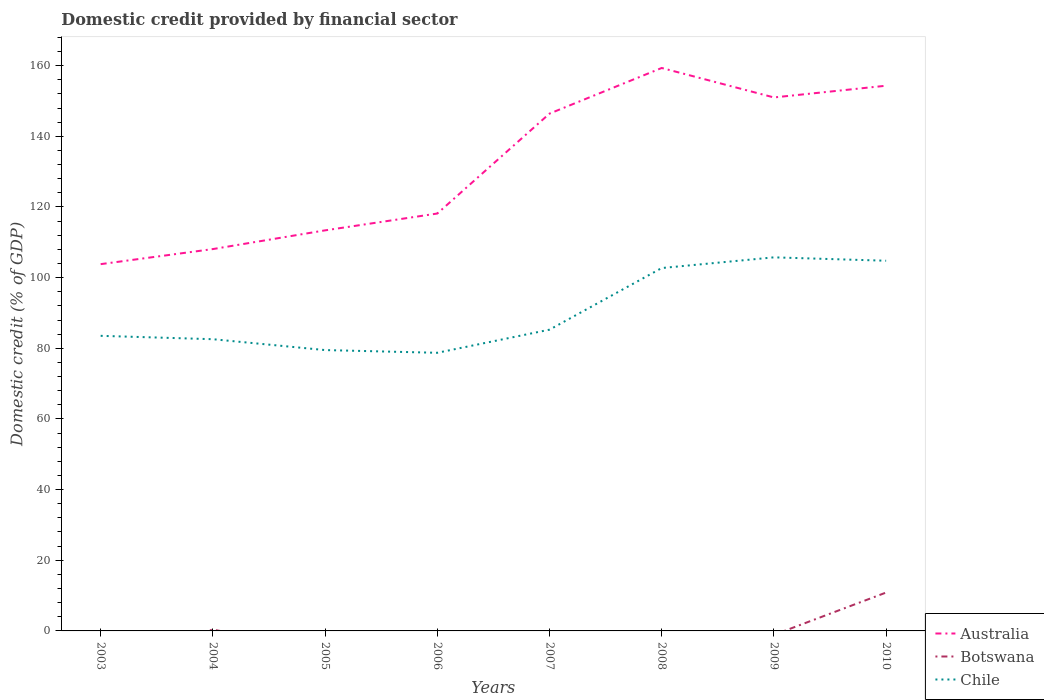How many different coloured lines are there?
Provide a short and direct response. 3. Does the line corresponding to Botswana intersect with the line corresponding to Chile?
Offer a very short reply. No. Is the number of lines equal to the number of legend labels?
Keep it short and to the point. No. Across all years, what is the maximum domestic credit in Chile?
Give a very brief answer. 78.72. What is the total domestic credit in Chile in the graph?
Offer a very short reply. -1.74. What is the difference between the highest and the second highest domestic credit in Australia?
Ensure brevity in your answer.  55.52. What is the difference between the highest and the lowest domestic credit in Chile?
Keep it short and to the point. 3. Is the domestic credit in Botswana strictly greater than the domestic credit in Australia over the years?
Your answer should be very brief. Yes. How many years are there in the graph?
Your answer should be compact. 8. Does the graph contain any zero values?
Offer a terse response. Yes. Where does the legend appear in the graph?
Make the answer very short. Bottom right. How many legend labels are there?
Make the answer very short. 3. How are the legend labels stacked?
Ensure brevity in your answer.  Vertical. What is the title of the graph?
Provide a succinct answer. Domestic credit provided by financial sector. Does "Central Europe" appear as one of the legend labels in the graph?
Your answer should be very brief. No. What is the label or title of the Y-axis?
Offer a very short reply. Domestic credit (% of GDP). What is the Domestic credit (% of GDP) in Australia in 2003?
Your answer should be very brief. 103.81. What is the Domestic credit (% of GDP) of Botswana in 2003?
Your answer should be compact. 0. What is the Domestic credit (% of GDP) of Chile in 2003?
Provide a short and direct response. 83.52. What is the Domestic credit (% of GDP) in Australia in 2004?
Your answer should be compact. 108.08. What is the Domestic credit (% of GDP) in Botswana in 2004?
Ensure brevity in your answer.  0.36. What is the Domestic credit (% of GDP) of Chile in 2004?
Keep it short and to the point. 82.56. What is the Domestic credit (% of GDP) of Australia in 2005?
Make the answer very short. 113.37. What is the Domestic credit (% of GDP) in Botswana in 2005?
Your answer should be very brief. 0. What is the Domestic credit (% of GDP) of Chile in 2005?
Your answer should be compact. 79.49. What is the Domestic credit (% of GDP) of Australia in 2006?
Offer a terse response. 118.14. What is the Domestic credit (% of GDP) in Botswana in 2006?
Your answer should be very brief. 0. What is the Domestic credit (% of GDP) of Chile in 2006?
Offer a very short reply. 78.72. What is the Domestic credit (% of GDP) of Australia in 2007?
Give a very brief answer. 146.42. What is the Domestic credit (% of GDP) of Chile in 2007?
Keep it short and to the point. 85.26. What is the Domestic credit (% of GDP) in Australia in 2008?
Your answer should be compact. 159.33. What is the Domestic credit (% of GDP) in Botswana in 2008?
Offer a terse response. 0. What is the Domestic credit (% of GDP) of Chile in 2008?
Your response must be concise. 102.71. What is the Domestic credit (% of GDP) of Australia in 2009?
Provide a succinct answer. 150.99. What is the Domestic credit (% of GDP) of Chile in 2009?
Provide a succinct answer. 105.73. What is the Domestic credit (% of GDP) of Australia in 2010?
Make the answer very short. 154.31. What is the Domestic credit (% of GDP) in Botswana in 2010?
Make the answer very short. 10.87. What is the Domestic credit (% of GDP) of Chile in 2010?
Make the answer very short. 104.78. Across all years, what is the maximum Domestic credit (% of GDP) of Australia?
Your response must be concise. 159.33. Across all years, what is the maximum Domestic credit (% of GDP) in Botswana?
Keep it short and to the point. 10.87. Across all years, what is the maximum Domestic credit (% of GDP) of Chile?
Your answer should be very brief. 105.73. Across all years, what is the minimum Domestic credit (% of GDP) in Australia?
Your answer should be very brief. 103.81. Across all years, what is the minimum Domestic credit (% of GDP) of Chile?
Offer a terse response. 78.72. What is the total Domestic credit (% of GDP) of Australia in the graph?
Provide a short and direct response. 1054.45. What is the total Domestic credit (% of GDP) of Botswana in the graph?
Provide a short and direct response. 11.23. What is the total Domestic credit (% of GDP) of Chile in the graph?
Provide a short and direct response. 722.78. What is the difference between the Domestic credit (% of GDP) of Australia in 2003 and that in 2004?
Offer a terse response. -4.27. What is the difference between the Domestic credit (% of GDP) of Chile in 2003 and that in 2004?
Keep it short and to the point. 0.96. What is the difference between the Domestic credit (% of GDP) in Australia in 2003 and that in 2005?
Provide a short and direct response. -9.56. What is the difference between the Domestic credit (% of GDP) in Chile in 2003 and that in 2005?
Keep it short and to the point. 4.03. What is the difference between the Domestic credit (% of GDP) of Australia in 2003 and that in 2006?
Provide a short and direct response. -14.33. What is the difference between the Domestic credit (% of GDP) in Chile in 2003 and that in 2006?
Make the answer very short. 4.8. What is the difference between the Domestic credit (% of GDP) in Australia in 2003 and that in 2007?
Keep it short and to the point. -42.61. What is the difference between the Domestic credit (% of GDP) of Chile in 2003 and that in 2007?
Keep it short and to the point. -1.74. What is the difference between the Domestic credit (% of GDP) of Australia in 2003 and that in 2008?
Provide a short and direct response. -55.52. What is the difference between the Domestic credit (% of GDP) of Chile in 2003 and that in 2008?
Provide a short and direct response. -19.19. What is the difference between the Domestic credit (% of GDP) in Australia in 2003 and that in 2009?
Ensure brevity in your answer.  -47.18. What is the difference between the Domestic credit (% of GDP) in Chile in 2003 and that in 2009?
Give a very brief answer. -22.21. What is the difference between the Domestic credit (% of GDP) of Australia in 2003 and that in 2010?
Your response must be concise. -50.51. What is the difference between the Domestic credit (% of GDP) in Chile in 2003 and that in 2010?
Your answer should be very brief. -21.25. What is the difference between the Domestic credit (% of GDP) of Australia in 2004 and that in 2005?
Your response must be concise. -5.3. What is the difference between the Domestic credit (% of GDP) of Chile in 2004 and that in 2005?
Offer a terse response. 3.07. What is the difference between the Domestic credit (% of GDP) of Australia in 2004 and that in 2006?
Make the answer very short. -10.06. What is the difference between the Domestic credit (% of GDP) in Chile in 2004 and that in 2006?
Ensure brevity in your answer.  3.84. What is the difference between the Domestic credit (% of GDP) in Australia in 2004 and that in 2007?
Ensure brevity in your answer.  -38.34. What is the difference between the Domestic credit (% of GDP) in Chile in 2004 and that in 2007?
Provide a short and direct response. -2.7. What is the difference between the Domestic credit (% of GDP) in Australia in 2004 and that in 2008?
Provide a short and direct response. -51.26. What is the difference between the Domestic credit (% of GDP) in Chile in 2004 and that in 2008?
Your response must be concise. -20.15. What is the difference between the Domestic credit (% of GDP) of Australia in 2004 and that in 2009?
Your response must be concise. -42.92. What is the difference between the Domestic credit (% of GDP) in Chile in 2004 and that in 2009?
Provide a short and direct response. -23.17. What is the difference between the Domestic credit (% of GDP) of Australia in 2004 and that in 2010?
Ensure brevity in your answer.  -46.24. What is the difference between the Domestic credit (% of GDP) in Botswana in 2004 and that in 2010?
Your answer should be compact. -10.5. What is the difference between the Domestic credit (% of GDP) in Chile in 2004 and that in 2010?
Your answer should be compact. -22.21. What is the difference between the Domestic credit (% of GDP) in Australia in 2005 and that in 2006?
Your response must be concise. -4.76. What is the difference between the Domestic credit (% of GDP) of Chile in 2005 and that in 2006?
Your answer should be very brief. 0.77. What is the difference between the Domestic credit (% of GDP) of Australia in 2005 and that in 2007?
Your answer should be compact. -33.04. What is the difference between the Domestic credit (% of GDP) in Chile in 2005 and that in 2007?
Ensure brevity in your answer.  -5.77. What is the difference between the Domestic credit (% of GDP) of Australia in 2005 and that in 2008?
Your answer should be very brief. -45.96. What is the difference between the Domestic credit (% of GDP) of Chile in 2005 and that in 2008?
Offer a terse response. -23.22. What is the difference between the Domestic credit (% of GDP) in Australia in 2005 and that in 2009?
Offer a terse response. -37.62. What is the difference between the Domestic credit (% of GDP) in Chile in 2005 and that in 2009?
Keep it short and to the point. -26.24. What is the difference between the Domestic credit (% of GDP) of Australia in 2005 and that in 2010?
Provide a succinct answer. -40.94. What is the difference between the Domestic credit (% of GDP) in Chile in 2005 and that in 2010?
Your answer should be very brief. -25.28. What is the difference between the Domestic credit (% of GDP) of Australia in 2006 and that in 2007?
Offer a very short reply. -28.28. What is the difference between the Domestic credit (% of GDP) in Chile in 2006 and that in 2007?
Your answer should be very brief. -6.54. What is the difference between the Domestic credit (% of GDP) in Australia in 2006 and that in 2008?
Offer a terse response. -41.2. What is the difference between the Domestic credit (% of GDP) of Chile in 2006 and that in 2008?
Ensure brevity in your answer.  -23.99. What is the difference between the Domestic credit (% of GDP) of Australia in 2006 and that in 2009?
Ensure brevity in your answer.  -32.86. What is the difference between the Domestic credit (% of GDP) of Chile in 2006 and that in 2009?
Make the answer very short. -27.01. What is the difference between the Domestic credit (% of GDP) of Australia in 2006 and that in 2010?
Your response must be concise. -36.18. What is the difference between the Domestic credit (% of GDP) in Chile in 2006 and that in 2010?
Your answer should be very brief. -26.06. What is the difference between the Domestic credit (% of GDP) of Australia in 2007 and that in 2008?
Give a very brief answer. -12.92. What is the difference between the Domestic credit (% of GDP) of Chile in 2007 and that in 2008?
Your response must be concise. -17.45. What is the difference between the Domestic credit (% of GDP) in Australia in 2007 and that in 2009?
Offer a terse response. -4.58. What is the difference between the Domestic credit (% of GDP) of Chile in 2007 and that in 2009?
Ensure brevity in your answer.  -20.47. What is the difference between the Domestic credit (% of GDP) of Australia in 2007 and that in 2010?
Provide a succinct answer. -7.9. What is the difference between the Domestic credit (% of GDP) in Chile in 2007 and that in 2010?
Provide a succinct answer. -19.51. What is the difference between the Domestic credit (% of GDP) in Australia in 2008 and that in 2009?
Your answer should be very brief. 8.34. What is the difference between the Domestic credit (% of GDP) in Chile in 2008 and that in 2009?
Offer a terse response. -3.02. What is the difference between the Domestic credit (% of GDP) in Australia in 2008 and that in 2010?
Your response must be concise. 5.02. What is the difference between the Domestic credit (% of GDP) of Chile in 2008 and that in 2010?
Your response must be concise. -2.07. What is the difference between the Domestic credit (% of GDP) in Australia in 2009 and that in 2010?
Your answer should be compact. -3.32. What is the difference between the Domestic credit (% of GDP) of Chile in 2009 and that in 2010?
Give a very brief answer. 0.96. What is the difference between the Domestic credit (% of GDP) of Australia in 2003 and the Domestic credit (% of GDP) of Botswana in 2004?
Provide a short and direct response. 103.45. What is the difference between the Domestic credit (% of GDP) of Australia in 2003 and the Domestic credit (% of GDP) of Chile in 2004?
Offer a very short reply. 21.24. What is the difference between the Domestic credit (% of GDP) in Australia in 2003 and the Domestic credit (% of GDP) in Chile in 2005?
Your answer should be very brief. 24.32. What is the difference between the Domestic credit (% of GDP) of Australia in 2003 and the Domestic credit (% of GDP) of Chile in 2006?
Offer a terse response. 25.09. What is the difference between the Domestic credit (% of GDP) in Australia in 2003 and the Domestic credit (% of GDP) in Chile in 2007?
Your answer should be very brief. 18.55. What is the difference between the Domestic credit (% of GDP) of Australia in 2003 and the Domestic credit (% of GDP) of Chile in 2008?
Make the answer very short. 1.1. What is the difference between the Domestic credit (% of GDP) in Australia in 2003 and the Domestic credit (% of GDP) in Chile in 2009?
Provide a succinct answer. -1.93. What is the difference between the Domestic credit (% of GDP) of Australia in 2003 and the Domestic credit (% of GDP) of Botswana in 2010?
Your answer should be very brief. 92.94. What is the difference between the Domestic credit (% of GDP) of Australia in 2003 and the Domestic credit (% of GDP) of Chile in 2010?
Give a very brief answer. -0.97. What is the difference between the Domestic credit (% of GDP) in Australia in 2004 and the Domestic credit (% of GDP) in Chile in 2005?
Keep it short and to the point. 28.59. What is the difference between the Domestic credit (% of GDP) in Botswana in 2004 and the Domestic credit (% of GDP) in Chile in 2005?
Provide a short and direct response. -79.13. What is the difference between the Domestic credit (% of GDP) in Australia in 2004 and the Domestic credit (% of GDP) in Chile in 2006?
Give a very brief answer. 29.36. What is the difference between the Domestic credit (% of GDP) in Botswana in 2004 and the Domestic credit (% of GDP) in Chile in 2006?
Keep it short and to the point. -78.36. What is the difference between the Domestic credit (% of GDP) in Australia in 2004 and the Domestic credit (% of GDP) in Chile in 2007?
Your answer should be compact. 22.81. What is the difference between the Domestic credit (% of GDP) of Botswana in 2004 and the Domestic credit (% of GDP) of Chile in 2007?
Give a very brief answer. -84.9. What is the difference between the Domestic credit (% of GDP) in Australia in 2004 and the Domestic credit (% of GDP) in Chile in 2008?
Provide a short and direct response. 5.37. What is the difference between the Domestic credit (% of GDP) in Botswana in 2004 and the Domestic credit (% of GDP) in Chile in 2008?
Make the answer very short. -102.35. What is the difference between the Domestic credit (% of GDP) in Australia in 2004 and the Domestic credit (% of GDP) in Chile in 2009?
Offer a terse response. 2.34. What is the difference between the Domestic credit (% of GDP) of Botswana in 2004 and the Domestic credit (% of GDP) of Chile in 2009?
Your answer should be very brief. -105.37. What is the difference between the Domestic credit (% of GDP) in Australia in 2004 and the Domestic credit (% of GDP) in Botswana in 2010?
Ensure brevity in your answer.  97.21. What is the difference between the Domestic credit (% of GDP) of Australia in 2004 and the Domestic credit (% of GDP) of Chile in 2010?
Give a very brief answer. 3.3. What is the difference between the Domestic credit (% of GDP) in Botswana in 2004 and the Domestic credit (% of GDP) in Chile in 2010?
Offer a very short reply. -104.41. What is the difference between the Domestic credit (% of GDP) in Australia in 2005 and the Domestic credit (% of GDP) in Chile in 2006?
Ensure brevity in your answer.  34.65. What is the difference between the Domestic credit (% of GDP) in Australia in 2005 and the Domestic credit (% of GDP) in Chile in 2007?
Make the answer very short. 28.11. What is the difference between the Domestic credit (% of GDP) in Australia in 2005 and the Domestic credit (% of GDP) in Chile in 2008?
Your answer should be compact. 10.66. What is the difference between the Domestic credit (% of GDP) of Australia in 2005 and the Domestic credit (% of GDP) of Chile in 2009?
Make the answer very short. 7.64. What is the difference between the Domestic credit (% of GDP) in Australia in 2005 and the Domestic credit (% of GDP) in Botswana in 2010?
Ensure brevity in your answer.  102.51. What is the difference between the Domestic credit (% of GDP) in Australia in 2005 and the Domestic credit (% of GDP) in Chile in 2010?
Your answer should be very brief. 8.6. What is the difference between the Domestic credit (% of GDP) in Australia in 2006 and the Domestic credit (% of GDP) in Chile in 2007?
Provide a short and direct response. 32.87. What is the difference between the Domestic credit (% of GDP) of Australia in 2006 and the Domestic credit (% of GDP) of Chile in 2008?
Your response must be concise. 15.43. What is the difference between the Domestic credit (% of GDP) in Australia in 2006 and the Domestic credit (% of GDP) in Chile in 2009?
Give a very brief answer. 12.4. What is the difference between the Domestic credit (% of GDP) of Australia in 2006 and the Domestic credit (% of GDP) of Botswana in 2010?
Provide a succinct answer. 107.27. What is the difference between the Domestic credit (% of GDP) in Australia in 2006 and the Domestic credit (% of GDP) in Chile in 2010?
Keep it short and to the point. 13.36. What is the difference between the Domestic credit (% of GDP) of Australia in 2007 and the Domestic credit (% of GDP) of Chile in 2008?
Your answer should be very brief. 43.71. What is the difference between the Domestic credit (% of GDP) of Australia in 2007 and the Domestic credit (% of GDP) of Chile in 2009?
Keep it short and to the point. 40.68. What is the difference between the Domestic credit (% of GDP) in Australia in 2007 and the Domestic credit (% of GDP) in Botswana in 2010?
Your answer should be very brief. 135.55. What is the difference between the Domestic credit (% of GDP) of Australia in 2007 and the Domestic credit (% of GDP) of Chile in 2010?
Your answer should be compact. 41.64. What is the difference between the Domestic credit (% of GDP) of Australia in 2008 and the Domestic credit (% of GDP) of Chile in 2009?
Provide a short and direct response. 53.6. What is the difference between the Domestic credit (% of GDP) in Australia in 2008 and the Domestic credit (% of GDP) in Botswana in 2010?
Your answer should be very brief. 148.47. What is the difference between the Domestic credit (% of GDP) of Australia in 2008 and the Domestic credit (% of GDP) of Chile in 2010?
Your answer should be compact. 54.56. What is the difference between the Domestic credit (% of GDP) of Australia in 2009 and the Domestic credit (% of GDP) of Botswana in 2010?
Your response must be concise. 140.13. What is the difference between the Domestic credit (% of GDP) in Australia in 2009 and the Domestic credit (% of GDP) in Chile in 2010?
Offer a very short reply. 46.22. What is the average Domestic credit (% of GDP) of Australia per year?
Offer a terse response. 131.81. What is the average Domestic credit (% of GDP) in Botswana per year?
Your response must be concise. 1.4. What is the average Domestic credit (% of GDP) in Chile per year?
Your response must be concise. 90.35. In the year 2003, what is the difference between the Domestic credit (% of GDP) of Australia and Domestic credit (% of GDP) of Chile?
Offer a terse response. 20.29. In the year 2004, what is the difference between the Domestic credit (% of GDP) in Australia and Domestic credit (% of GDP) in Botswana?
Your answer should be very brief. 107.72. In the year 2004, what is the difference between the Domestic credit (% of GDP) in Australia and Domestic credit (% of GDP) in Chile?
Give a very brief answer. 25.51. In the year 2004, what is the difference between the Domestic credit (% of GDP) in Botswana and Domestic credit (% of GDP) in Chile?
Make the answer very short. -82.2. In the year 2005, what is the difference between the Domestic credit (% of GDP) in Australia and Domestic credit (% of GDP) in Chile?
Give a very brief answer. 33.88. In the year 2006, what is the difference between the Domestic credit (% of GDP) of Australia and Domestic credit (% of GDP) of Chile?
Provide a succinct answer. 39.42. In the year 2007, what is the difference between the Domestic credit (% of GDP) of Australia and Domestic credit (% of GDP) of Chile?
Your response must be concise. 61.15. In the year 2008, what is the difference between the Domestic credit (% of GDP) in Australia and Domestic credit (% of GDP) in Chile?
Provide a short and direct response. 56.62. In the year 2009, what is the difference between the Domestic credit (% of GDP) of Australia and Domestic credit (% of GDP) of Chile?
Provide a succinct answer. 45.26. In the year 2010, what is the difference between the Domestic credit (% of GDP) of Australia and Domestic credit (% of GDP) of Botswana?
Your answer should be compact. 143.45. In the year 2010, what is the difference between the Domestic credit (% of GDP) in Australia and Domestic credit (% of GDP) in Chile?
Provide a succinct answer. 49.54. In the year 2010, what is the difference between the Domestic credit (% of GDP) in Botswana and Domestic credit (% of GDP) in Chile?
Provide a short and direct response. -93.91. What is the ratio of the Domestic credit (% of GDP) in Australia in 2003 to that in 2004?
Offer a very short reply. 0.96. What is the ratio of the Domestic credit (% of GDP) of Chile in 2003 to that in 2004?
Provide a succinct answer. 1.01. What is the ratio of the Domestic credit (% of GDP) in Australia in 2003 to that in 2005?
Give a very brief answer. 0.92. What is the ratio of the Domestic credit (% of GDP) in Chile in 2003 to that in 2005?
Your answer should be very brief. 1.05. What is the ratio of the Domestic credit (% of GDP) of Australia in 2003 to that in 2006?
Your answer should be very brief. 0.88. What is the ratio of the Domestic credit (% of GDP) of Chile in 2003 to that in 2006?
Make the answer very short. 1.06. What is the ratio of the Domestic credit (% of GDP) of Australia in 2003 to that in 2007?
Provide a succinct answer. 0.71. What is the ratio of the Domestic credit (% of GDP) in Chile in 2003 to that in 2007?
Provide a succinct answer. 0.98. What is the ratio of the Domestic credit (% of GDP) of Australia in 2003 to that in 2008?
Your answer should be compact. 0.65. What is the ratio of the Domestic credit (% of GDP) of Chile in 2003 to that in 2008?
Provide a short and direct response. 0.81. What is the ratio of the Domestic credit (% of GDP) of Australia in 2003 to that in 2009?
Offer a terse response. 0.69. What is the ratio of the Domestic credit (% of GDP) in Chile in 2003 to that in 2009?
Provide a succinct answer. 0.79. What is the ratio of the Domestic credit (% of GDP) in Australia in 2003 to that in 2010?
Make the answer very short. 0.67. What is the ratio of the Domestic credit (% of GDP) of Chile in 2003 to that in 2010?
Offer a terse response. 0.8. What is the ratio of the Domestic credit (% of GDP) of Australia in 2004 to that in 2005?
Keep it short and to the point. 0.95. What is the ratio of the Domestic credit (% of GDP) of Chile in 2004 to that in 2005?
Make the answer very short. 1.04. What is the ratio of the Domestic credit (% of GDP) in Australia in 2004 to that in 2006?
Offer a very short reply. 0.91. What is the ratio of the Domestic credit (% of GDP) in Chile in 2004 to that in 2006?
Your answer should be compact. 1.05. What is the ratio of the Domestic credit (% of GDP) in Australia in 2004 to that in 2007?
Your response must be concise. 0.74. What is the ratio of the Domestic credit (% of GDP) of Chile in 2004 to that in 2007?
Offer a very short reply. 0.97. What is the ratio of the Domestic credit (% of GDP) in Australia in 2004 to that in 2008?
Give a very brief answer. 0.68. What is the ratio of the Domestic credit (% of GDP) in Chile in 2004 to that in 2008?
Provide a short and direct response. 0.8. What is the ratio of the Domestic credit (% of GDP) in Australia in 2004 to that in 2009?
Offer a very short reply. 0.72. What is the ratio of the Domestic credit (% of GDP) in Chile in 2004 to that in 2009?
Your answer should be compact. 0.78. What is the ratio of the Domestic credit (% of GDP) of Australia in 2004 to that in 2010?
Offer a terse response. 0.7. What is the ratio of the Domestic credit (% of GDP) in Botswana in 2004 to that in 2010?
Ensure brevity in your answer.  0.03. What is the ratio of the Domestic credit (% of GDP) in Chile in 2004 to that in 2010?
Provide a succinct answer. 0.79. What is the ratio of the Domestic credit (% of GDP) of Australia in 2005 to that in 2006?
Ensure brevity in your answer.  0.96. What is the ratio of the Domestic credit (% of GDP) in Chile in 2005 to that in 2006?
Your response must be concise. 1.01. What is the ratio of the Domestic credit (% of GDP) in Australia in 2005 to that in 2007?
Your answer should be compact. 0.77. What is the ratio of the Domestic credit (% of GDP) in Chile in 2005 to that in 2007?
Your answer should be very brief. 0.93. What is the ratio of the Domestic credit (% of GDP) of Australia in 2005 to that in 2008?
Give a very brief answer. 0.71. What is the ratio of the Domestic credit (% of GDP) of Chile in 2005 to that in 2008?
Keep it short and to the point. 0.77. What is the ratio of the Domestic credit (% of GDP) of Australia in 2005 to that in 2009?
Ensure brevity in your answer.  0.75. What is the ratio of the Domestic credit (% of GDP) of Chile in 2005 to that in 2009?
Provide a short and direct response. 0.75. What is the ratio of the Domestic credit (% of GDP) in Australia in 2005 to that in 2010?
Offer a terse response. 0.73. What is the ratio of the Domestic credit (% of GDP) of Chile in 2005 to that in 2010?
Ensure brevity in your answer.  0.76. What is the ratio of the Domestic credit (% of GDP) of Australia in 2006 to that in 2007?
Your answer should be very brief. 0.81. What is the ratio of the Domestic credit (% of GDP) of Chile in 2006 to that in 2007?
Your answer should be very brief. 0.92. What is the ratio of the Domestic credit (% of GDP) in Australia in 2006 to that in 2008?
Your answer should be compact. 0.74. What is the ratio of the Domestic credit (% of GDP) of Chile in 2006 to that in 2008?
Give a very brief answer. 0.77. What is the ratio of the Domestic credit (% of GDP) in Australia in 2006 to that in 2009?
Your answer should be very brief. 0.78. What is the ratio of the Domestic credit (% of GDP) in Chile in 2006 to that in 2009?
Give a very brief answer. 0.74. What is the ratio of the Domestic credit (% of GDP) in Australia in 2006 to that in 2010?
Offer a very short reply. 0.77. What is the ratio of the Domestic credit (% of GDP) of Chile in 2006 to that in 2010?
Give a very brief answer. 0.75. What is the ratio of the Domestic credit (% of GDP) of Australia in 2007 to that in 2008?
Your answer should be compact. 0.92. What is the ratio of the Domestic credit (% of GDP) of Chile in 2007 to that in 2008?
Provide a succinct answer. 0.83. What is the ratio of the Domestic credit (% of GDP) in Australia in 2007 to that in 2009?
Your answer should be compact. 0.97. What is the ratio of the Domestic credit (% of GDP) of Chile in 2007 to that in 2009?
Provide a short and direct response. 0.81. What is the ratio of the Domestic credit (% of GDP) in Australia in 2007 to that in 2010?
Provide a succinct answer. 0.95. What is the ratio of the Domestic credit (% of GDP) in Chile in 2007 to that in 2010?
Offer a very short reply. 0.81. What is the ratio of the Domestic credit (% of GDP) in Australia in 2008 to that in 2009?
Your answer should be very brief. 1.06. What is the ratio of the Domestic credit (% of GDP) in Chile in 2008 to that in 2009?
Keep it short and to the point. 0.97. What is the ratio of the Domestic credit (% of GDP) in Australia in 2008 to that in 2010?
Your answer should be compact. 1.03. What is the ratio of the Domestic credit (% of GDP) in Chile in 2008 to that in 2010?
Your answer should be compact. 0.98. What is the ratio of the Domestic credit (% of GDP) in Australia in 2009 to that in 2010?
Your answer should be compact. 0.98. What is the ratio of the Domestic credit (% of GDP) of Chile in 2009 to that in 2010?
Provide a succinct answer. 1.01. What is the difference between the highest and the second highest Domestic credit (% of GDP) of Australia?
Provide a succinct answer. 5.02. What is the difference between the highest and the second highest Domestic credit (% of GDP) in Chile?
Provide a short and direct response. 0.96. What is the difference between the highest and the lowest Domestic credit (% of GDP) of Australia?
Give a very brief answer. 55.52. What is the difference between the highest and the lowest Domestic credit (% of GDP) in Botswana?
Ensure brevity in your answer.  10.87. What is the difference between the highest and the lowest Domestic credit (% of GDP) in Chile?
Keep it short and to the point. 27.01. 